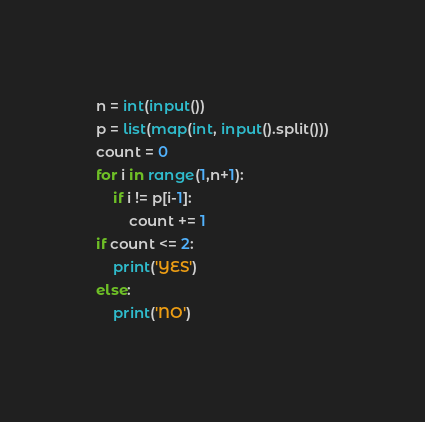Convert code to text. <code><loc_0><loc_0><loc_500><loc_500><_Python_>n = int(input())
p = list(map(int, input().split()))
count = 0
for i in range(1,n+1):
    if i != p[i-1]:
        count += 1
if count <= 2:
    print('YES')
else:
    print('NO')</code> 